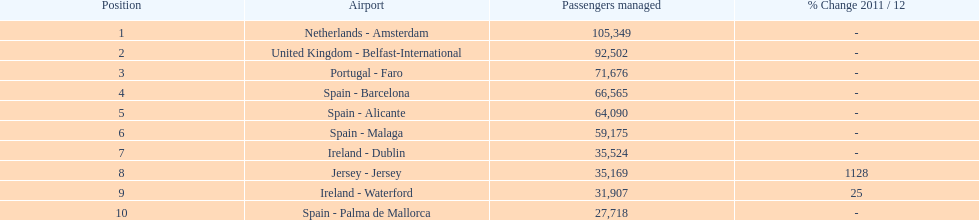How many airports in spain are among the 10 busiest routes to and from london southend airport in 2012? 4. 